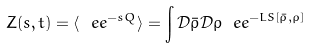Convert formula to latex. <formula><loc_0><loc_0><loc_500><loc_500>Z ( s , t ) = \langle \ e e ^ { - s Q } \rangle = \int \mathcal { D } \bar { \rho } \mathcal { D } \rho \ e e ^ { - L S [ \bar { \rho } , \rho ] }</formula> 